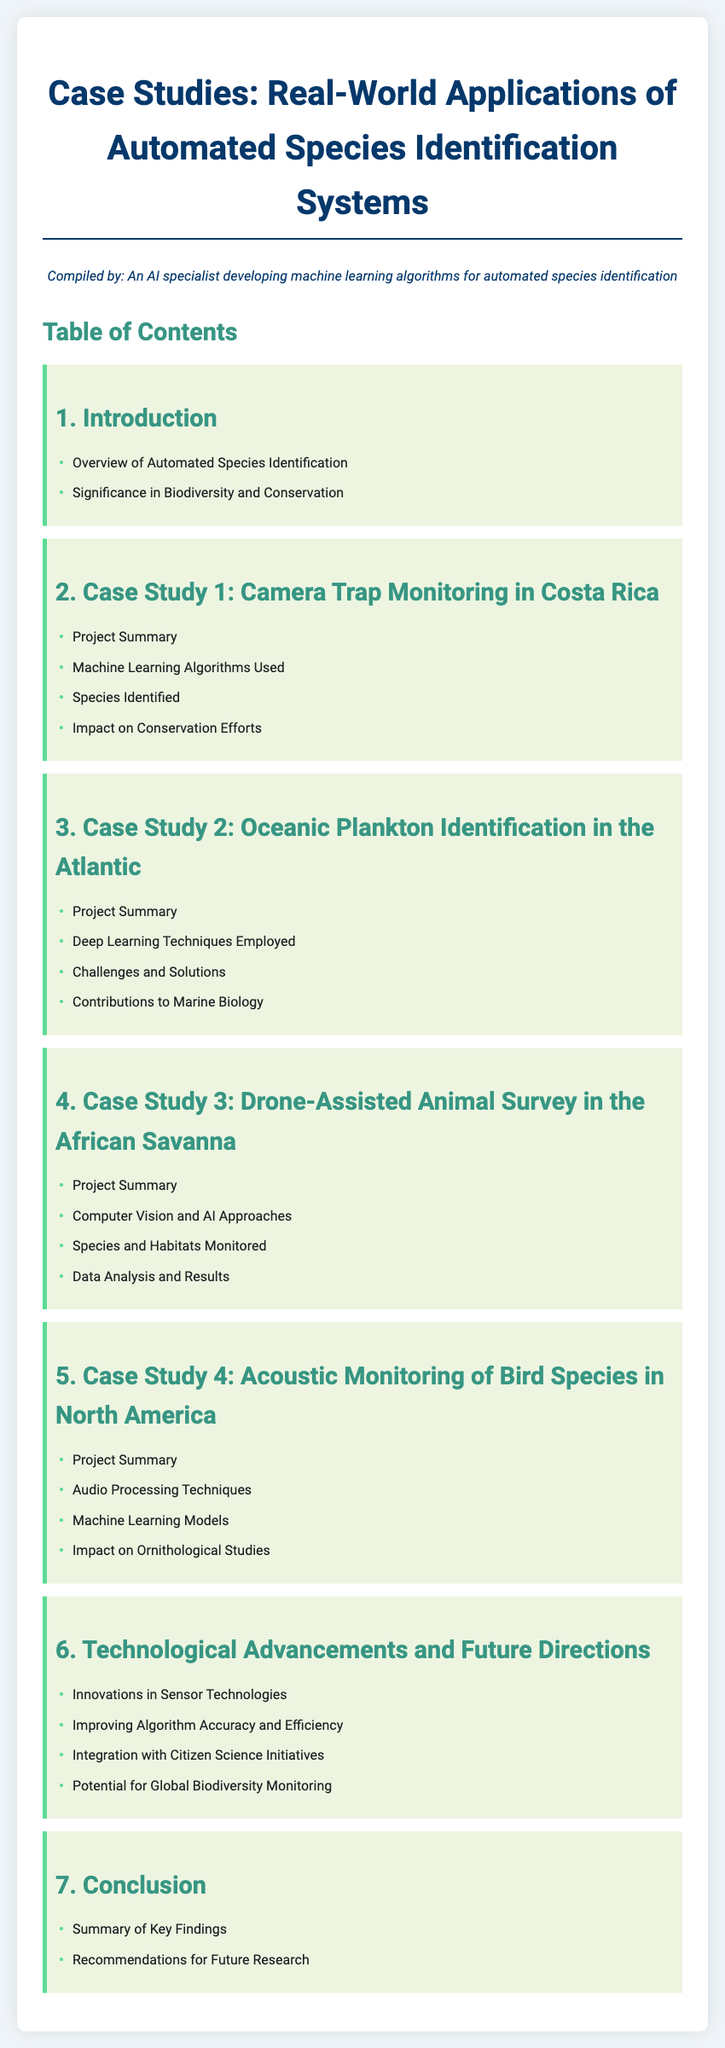What is the title of the document? The title of the document is explicitly stated at the top and is "Case Studies: Real-World Applications of Automated Species Identification Systems".
Answer: Case Studies: Real-World Applications of Automated Species Identification Systems How many case studies are mentioned? The document contains a total of four specific case studies outlined in the table of contents.
Answer: 4 What are the two key areas covered in the introduction? The introduction section lists two specific areas of coverage which are "Overview of Automated Species Identification" and "Significance in Biodiversity and Conservation".
Answer: Overview of Automated Species Identification, Significance in Biodiversity and Conservation Which technology is highlighted in Case Study 2? The section on Case Study 2 specifies the use of "Deep Learning Techniques" for oceanic plankton identification.
Answer: Deep Learning Techniques What is discussed under the conclusion section? The conclusion section summarizes the "Summary of Key Findings" and "Recommendations for Future Research" which are significant outcomes from the case studies.
Answer: Summary of Key Findings, Recommendations for Future Research Which monitoring method is used in Case Study 4? Case Study 4 emphasizes the use of "Acoustic Monitoring" for identifying bird species in North America.
Answer: Acoustic Monitoring What is one of the topics covered under technological advancements? One of the topics refers to "Innovations in Sensor Technologies", which is part of the discussion on future directions.
Answer: Innovations in Sensor Technologies What is a focus area in Case Study 3 regarding data? Case Study 3 mentions "Data Analysis and Results" as a key focus area concerning drone-assisted animal surveys.
Answer: Data Analysis and Results 